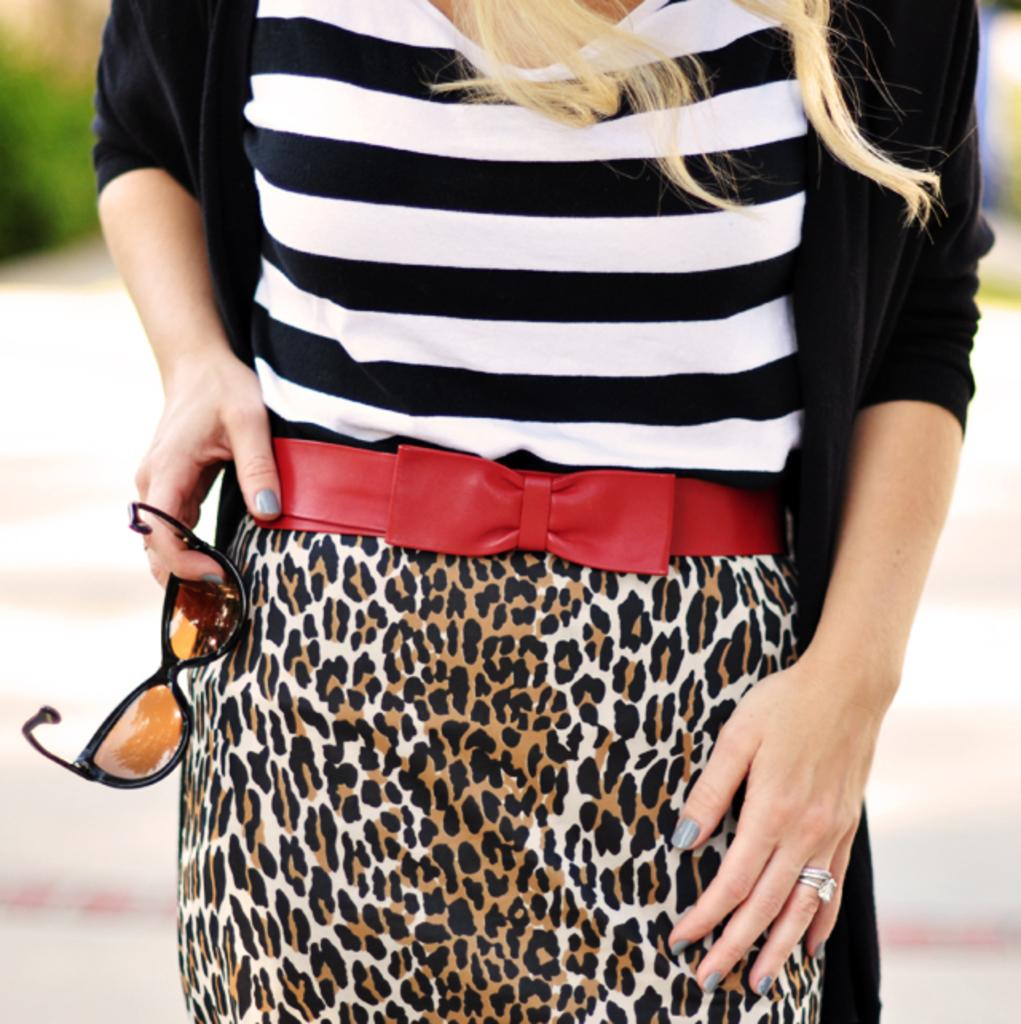Who is present in the image? There is a woman in the image. What is the woman holding in her hand? The woman is holding goggles in her hand. What is the woman's posture in the image? The woman is standing in the image. What color is the jacket the woman is wearing? The woman is wearing a black color jacket. Can you describe the background of the image? The background of the image is blurred. What type of seed is the woman planting in the image? There is no seed or planting activity present in the image; the woman is holding goggles. 